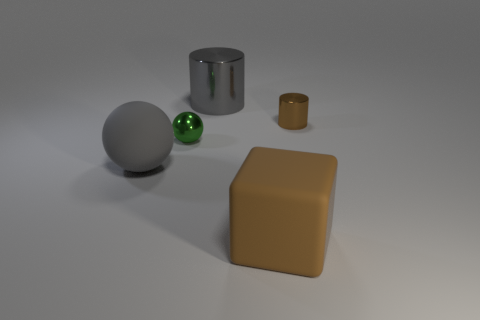Add 2 small purple rubber objects. How many objects exist? 7 Subtract all balls. How many objects are left? 3 Add 5 green rubber cylinders. How many green rubber cylinders exist? 5 Subtract 0 green blocks. How many objects are left? 5 Subtract all tiny purple metal spheres. Subtract all small brown cylinders. How many objects are left? 4 Add 1 tiny brown metallic objects. How many tiny brown metallic objects are left? 2 